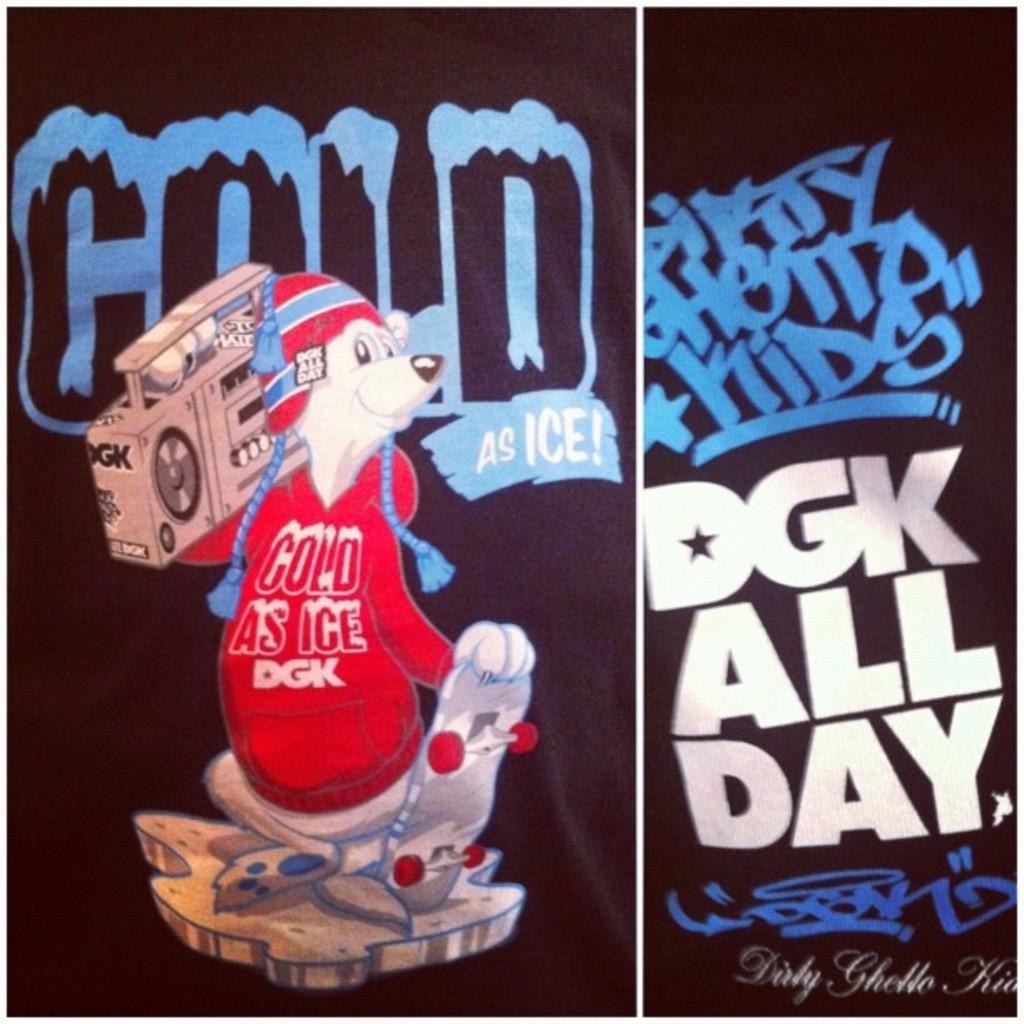Please provide a concise description of this image. In this image I can see the collage picture in which I can see the black colored cloth and on it I can see an animal wearing red colored dress is holding a skateboard and an electric device. I can see something is written on the black colored surface. 